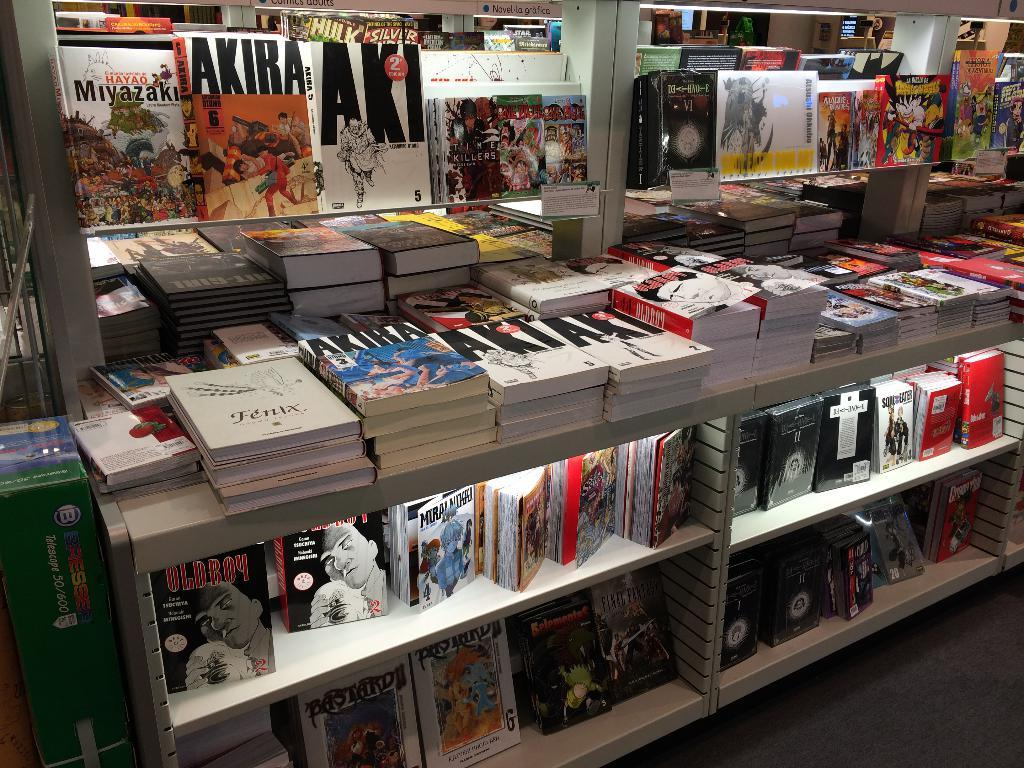<image>
Write a terse but informative summary of the picture. Book store that has a book called FENIX on the top. 